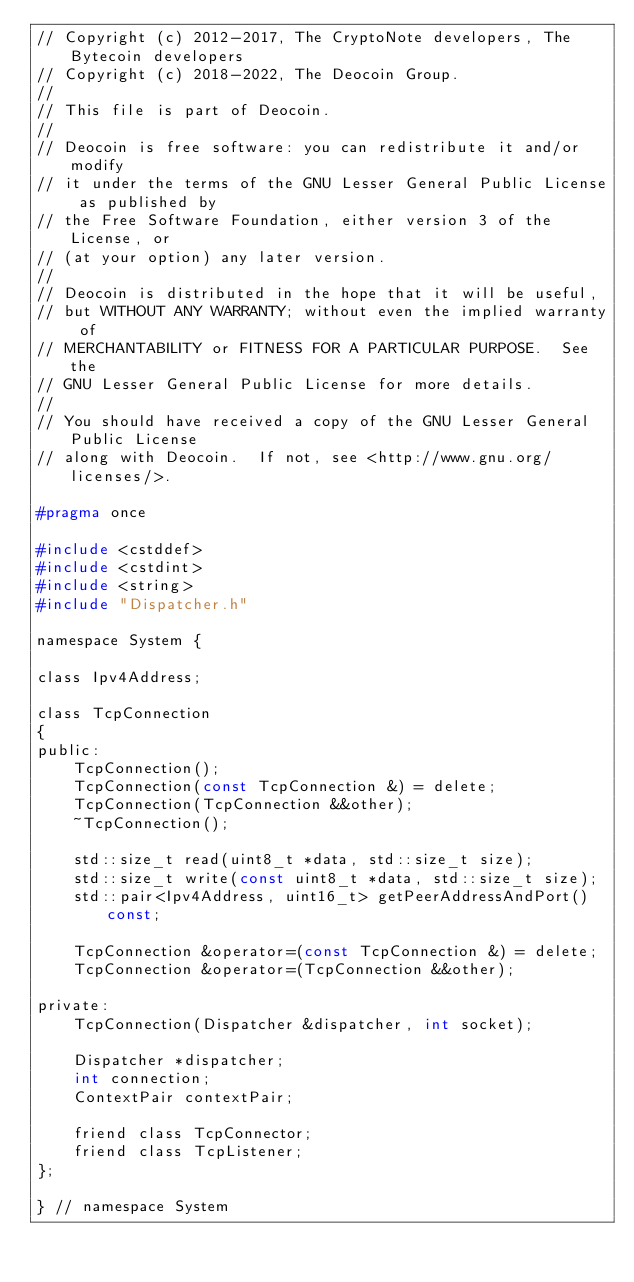<code> <loc_0><loc_0><loc_500><loc_500><_C_>// Copyright (c) 2012-2017, The CryptoNote developers, The Bytecoin developers
// Copyright (c) 2018-2022, The Deocoin Group.
//
// This file is part of Deocoin.
//
// Deocoin is free software: you can redistribute it and/or modify
// it under the terms of the GNU Lesser General Public License as published by
// the Free Software Foundation, either version 3 of the License, or
// (at your option) any later version.
//
// Deocoin is distributed in the hope that it will be useful,
// but WITHOUT ANY WARRANTY; without even the implied warranty of
// MERCHANTABILITY or FITNESS FOR A PARTICULAR PURPOSE.  See the
// GNU Lesser General Public License for more details.
//
// You should have received a copy of the GNU Lesser General Public License
// along with Deocoin.  If not, see <http://www.gnu.org/licenses/>.

#pragma once

#include <cstddef>
#include <cstdint>
#include <string>
#include "Dispatcher.h"

namespace System {

class Ipv4Address;

class TcpConnection
{
public:
    TcpConnection();
    TcpConnection(const TcpConnection &) = delete;
    TcpConnection(TcpConnection &&other);
    ~TcpConnection();

    std::size_t read(uint8_t *data, std::size_t size);
    std::size_t write(const uint8_t *data, std::size_t size);
    std::pair<Ipv4Address, uint16_t> getPeerAddressAndPort() const;

    TcpConnection &operator=(const TcpConnection &) = delete;
    TcpConnection &operator=(TcpConnection &&other);

private:
    TcpConnection(Dispatcher &dispatcher, int socket);

    Dispatcher *dispatcher;
    int connection;
    ContextPair contextPair;

    friend class TcpConnector;
    friend class TcpListener;
};

} // namespace System
</code> 